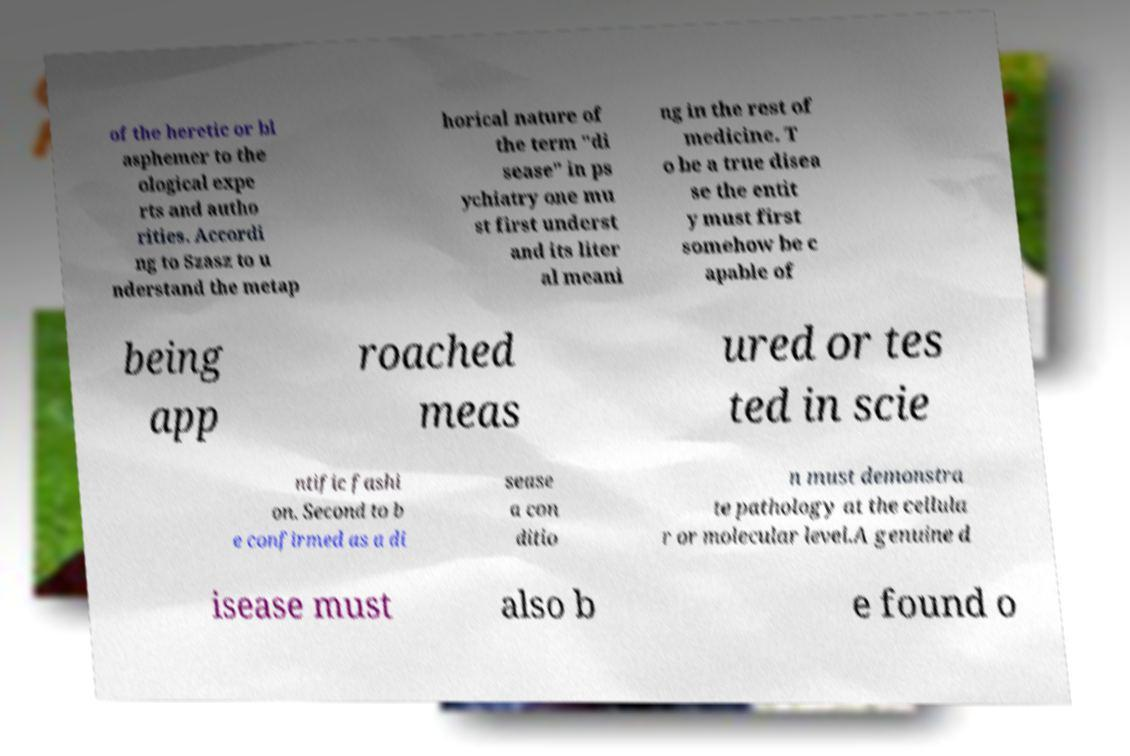Please identify and transcribe the text found in this image. of the heretic or bl asphemer to the ological expe rts and autho rities. Accordi ng to Szasz to u nderstand the metap horical nature of the term "di sease" in ps ychiatry one mu st first underst and its liter al meani ng in the rest of medicine. T o be a true disea se the entit y must first somehow be c apable of being app roached meas ured or tes ted in scie ntific fashi on. Second to b e confirmed as a di sease a con ditio n must demonstra te pathology at the cellula r or molecular level.A genuine d isease must also b e found o 